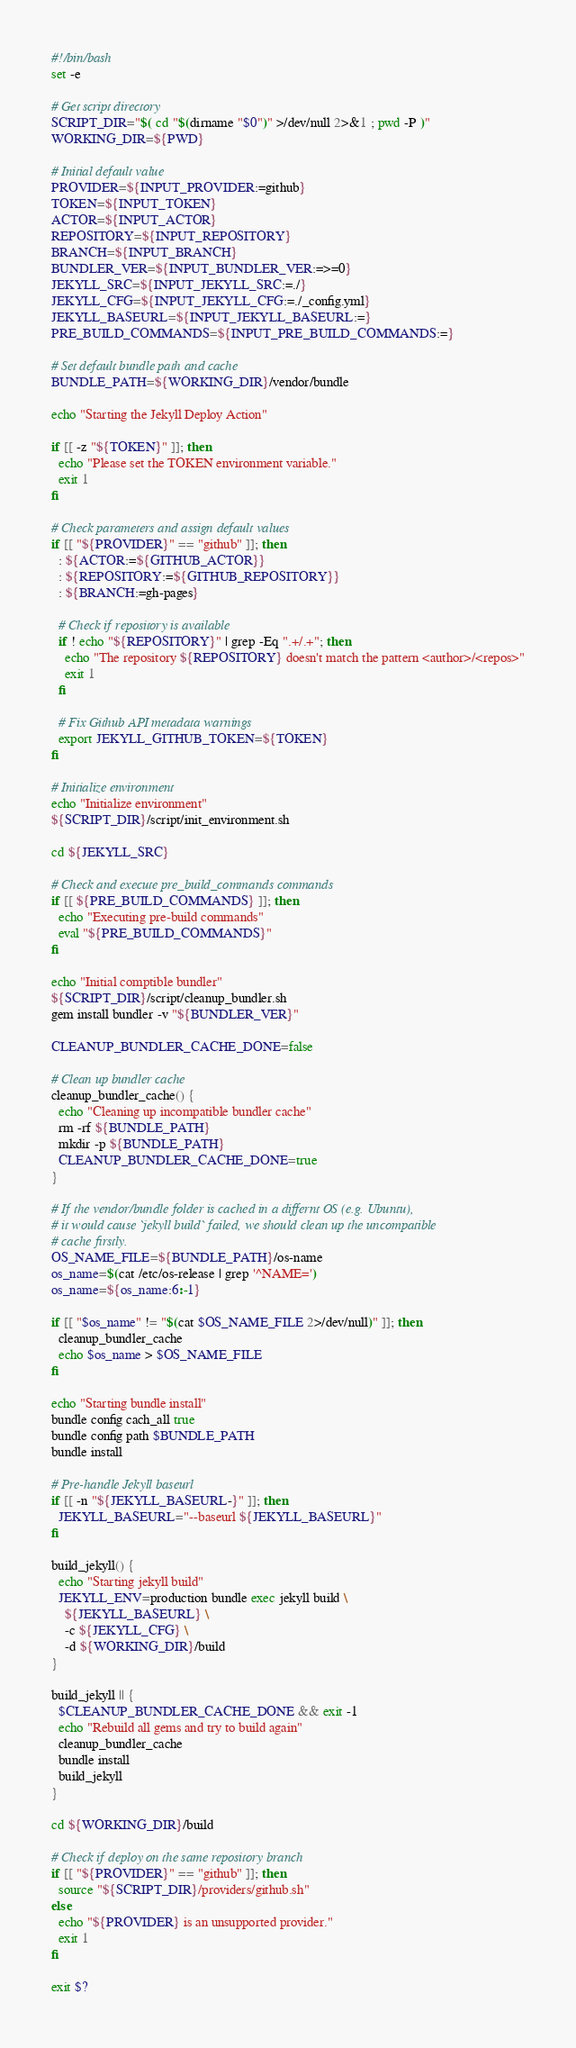<code> <loc_0><loc_0><loc_500><loc_500><_Bash_>#!/bin/bash
set -e

# Get script directory
SCRIPT_DIR="$( cd "$(dirname "$0")" >/dev/null 2>&1 ; pwd -P )"
WORKING_DIR=${PWD}

# Initial default value
PROVIDER=${INPUT_PROVIDER:=github}
TOKEN=${INPUT_TOKEN}
ACTOR=${INPUT_ACTOR}
REPOSITORY=${INPUT_REPOSITORY}
BRANCH=${INPUT_BRANCH}
BUNDLER_VER=${INPUT_BUNDLER_VER:=>=0}
JEKYLL_SRC=${INPUT_JEKYLL_SRC:=./}
JEKYLL_CFG=${INPUT_JEKYLL_CFG:=./_config.yml}
JEKYLL_BASEURL=${INPUT_JEKYLL_BASEURL:=}
PRE_BUILD_COMMANDS=${INPUT_PRE_BUILD_COMMANDS:=}

# Set default bundle path and cache
BUNDLE_PATH=${WORKING_DIR}/vendor/bundle

echo "Starting the Jekyll Deploy Action"

if [[ -z "${TOKEN}" ]]; then
  echo "Please set the TOKEN environment variable."
  exit 1
fi

# Check parameters and assign default values
if [[ "${PROVIDER}" == "github" ]]; then
  : ${ACTOR:=${GITHUB_ACTOR}}
  : ${REPOSITORY:=${GITHUB_REPOSITORY}}
  : ${BRANCH:=gh-pages}

  # Check if repository is available
  if ! echo "${REPOSITORY}" | grep -Eq ".+/.+"; then
    echo "The repository ${REPOSITORY} doesn't match the pattern <author>/<repos>"
    exit 1
  fi

  # Fix Github API metadata warnings
  export JEKYLL_GITHUB_TOKEN=${TOKEN}
fi

# Initialize environment
echo "Initialize environment"
${SCRIPT_DIR}/script/init_environment.sh

cd ${JEKYLL_SRC}

# Check and execute pre_build_commands commands
if [[ ${PRE_BUILD_COMMANDS} ]]; then
  echo "Executing pre-build commands"
  eval "${PRE_BUILD_COMMANDS}"
fi

echo "Initial comptible bundler"
${SCRIPT_DIR}/script/cleanup_bundler.sh
gem install bundler -v "${BUNDLER_VER}"

CLEANUP_BUNDLER_CACHE_DONE=false

# Clean up bundler cache
cleanup_bundler_cache() {
  echo "Cleaning up incompatible bundler cache"
  rm -rf ${BUNDLE_PATH}
  mkdir -p ${BUNDLE_PATH}
  CLEANUP_BUNDLER_CACHE_DONE=true
}

# If the vendor/bundle folder is cached in a differnt OS (e.g. Ubuntu),
# it would cause `jekyll build` failed, we should clean up the uncompatible
# cache firstly.
OS_NAME_FILE=${BUNDLE_PATH}/os-name
os_name=$(cat /etc/os-release | grep '^NAME=')
os_name=${os_name:6:-1}

if [[ "$os_name" != "$(cat $OS_NAME_FILE 2>/dev/null)" ]]; then
  cleanup_bundler_cache
  echo $os_name > $OS_NAME_FILE
fi

echo "Starting bundle install"
bundle config cach_all true
bundle config path $BUNDLE_PATH
bundle install

# Pre-handle Jekyll baseurl
if [[ -n "${JEKYLL_BASEURL-}" ]]; then
  JEKYLL_BASEURL="--baseurl ${JEKYLL_BASEURL}"
fi

build_jekyll() {
  echo "Starting jekyll build"
  JEKYLL_ENV=production bundle exec jekyll build \
    ${JEKYLL_BASEURL} \
    -c ${JEKYLL_CFG} \
    -d ${WORKING_DIR}/build
}

build_jekyll || {
  $CLEANUP_BUNDLER_CACHE_DONE && exit -1
  echo "Rebuild all gems and try to build again"
  cleanup_bundler_cache
  bundle install
  build_jekyll
}

cd ${WORKING_DIR}/build

# Check if deploy on the same repository branch
if [[ "${PROVIDER}" == "github" ]]; then
  source "${SCRIPT_DIR}/providers/github.sh"
else
  echo "${PROVIDER} is an unsupported provider."
  exit 1
fi

exit $?
</code> 